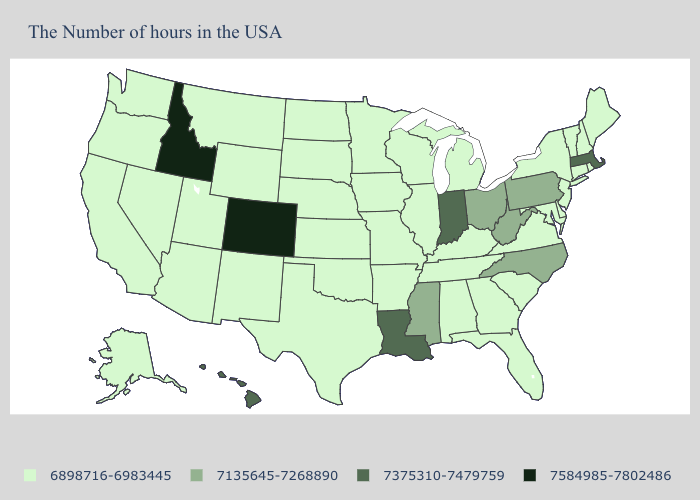How many symbols are there in the legend?
Keep it brief. 4. Name the states that have a value in the range 7375310-7479759?
Give a very brief answer. Massachusetts, Indiana, Louisiana, Hawaii. Does Ohio have a higher value than Louisiana?
Give a very brief answer. No. How many symbols are there in the legend?
Quick response, please. 4. Which states have the lowest value in the USA?
Concise answer only. Maine, Rhode Island, New Hampshire, Vermont, Connecticut, New York, New Jersey, Delaware, Maryland, Virginia, South Carolina, Florida, Georgia, Michigan, Kentucky, Alabama, Tennessee, Wisconsin, Illinois, Missouri, Arkansas, Minnesota, Iowa, Kansas, Nebraska, Oklahoma, Texas, South Dakota, North Dakota, Wyoming, New Mexico, Utah, Montana, Arizona, Nevada, California, Washington, Oregon, Alaska. Name the states that have a value in the range 7375310-7479759?
Short answer required. Massachusetts, Indiana, Louisiana, Hawaii. What is the value of Michigan?
Keep it brief. 6898716-6983445. Does Montana have the highest value in the West?
Keep it brief. No. What is the highest value in the MidWest ?
Give a very brief answer. 7375310-7479759. What is the lowest value in states that border Nebraska?
Be succinct. 6898716-6983445. Does Louisiana have the highest value in the USA?
Write a very short answer. No. Name the states that have a value in the range 6898716-6983445?
Write a very short answer. Maine, Rhode Island, New Hampshire, Vermont, Connecticut, New York, New Jersey, Delaware, Maryland, Virginia, South Carolina, Florida, Georgia, Michigan, Kentucky, Alabama, Tennessee, Wisconsin, Illinois, Missouri, Arkansas, Minnesota, Iowa, Kansas, Nebraska, Oklahoma, Texas, South Dakota, North Dakota, Wyoming, New Mexico, Utah, Montana, Arizona, Nevada, California, Washington, Oregon, Alaska. Among the states that border Mississippi , does Louisiana have the highest value?
Concise answer only. Yes. What is the value of Wyoming?
Quick response, please. 6898716-6983445. Does Maryland have the highest value in the USA?
Quick response, please. No. 